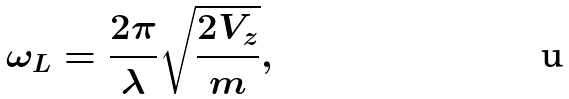<formula> <loc_0><loc_0><loc_500><loc_500>\omega _ { L } = \frac { 2 \pi } { \lambda } \sqrt { \frac { 2 V _ { z } } { m } } ,</formula> 